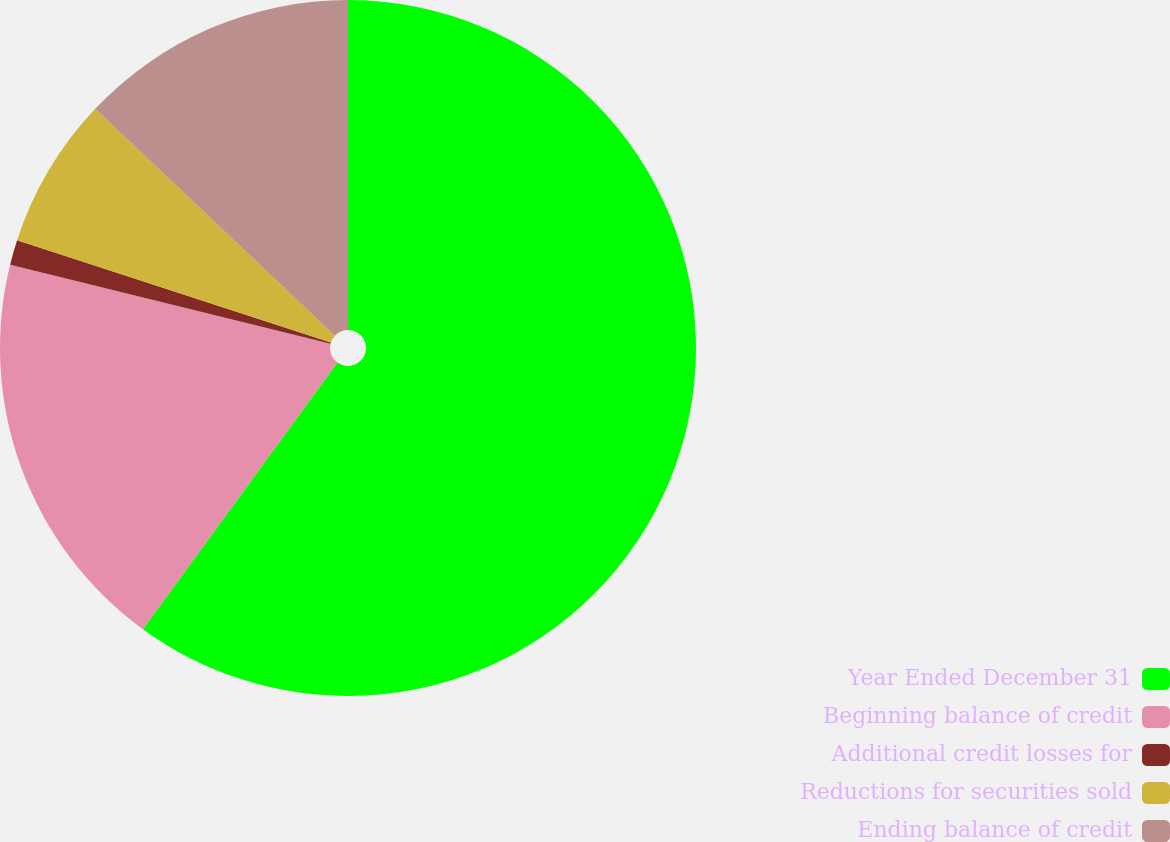Convert chart to OTSL. <chart><loc_0><loc_0><loc_500><loc_500><pie_chart><fcel>Year Ended December 31<fcel>Beginning balance of credit<fcel>Additional credit losses for<fcel>Reductions for securities sold<fcel>Ending balance of credit<nl><fcel>60.03%<fcel>18.82%<fcel>1.16%<fcel>7.05%<fcel>12.94%<nl></chart> 